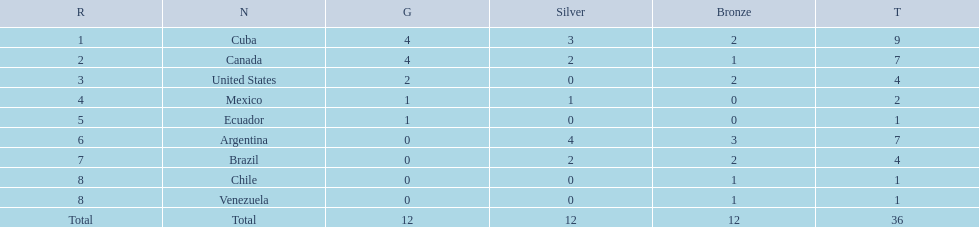What were the amounts of bronze medals won by the countries? 2, 1, 2, 0, 0, 3, 2, 1, 1. Which is the highest? 3. Which nation had this amount? Argentina. 